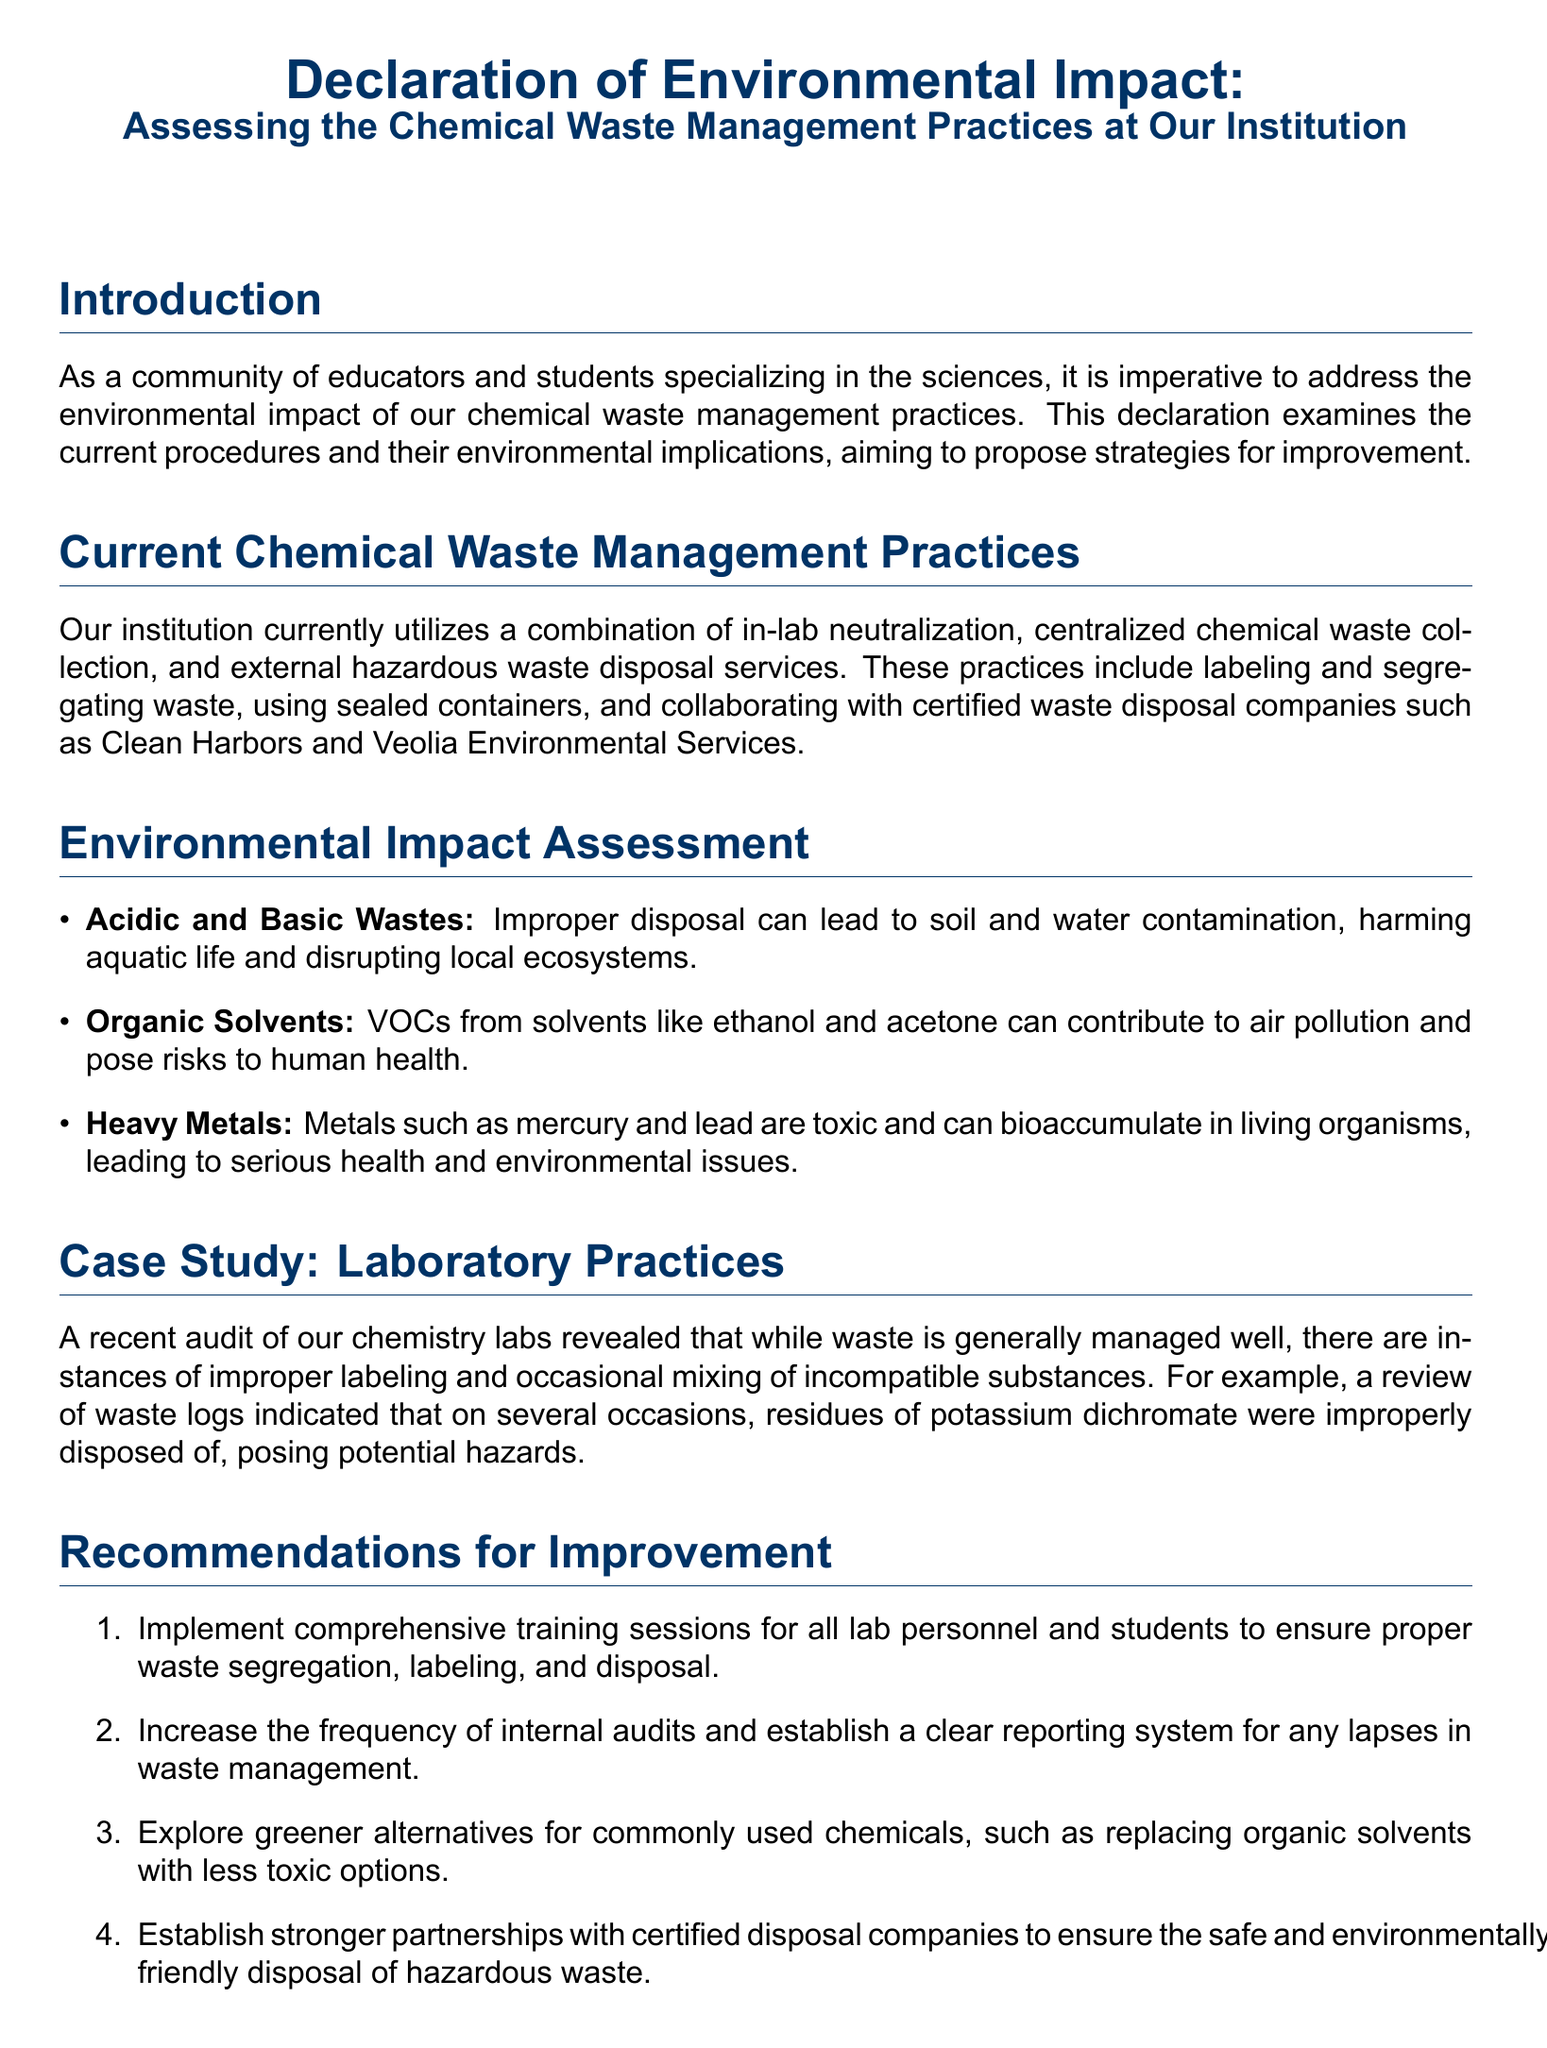What is the title of the document? The title is provided in the introduction section and is a clear representation of the document's focus.
Answer: Declaration of Environmental Impact: Assessing the Chemical Waste Management Practices at Our Institution What companies are mentioned for waste disposal? These companies are referenced in the context of external services utilized for chemical waste disposal.
Answer: Clean Harbors and Veolia Environmental Services What is one type of waste discussed in the environmental impact assessment? The document lists specific types of waste and their implications for the environment, indicating a focus on various waste categories.
Answer: Acidic and Basic Wastes What is one recommendation made for improving waste management? The recommendations section provides actionable steps aimed at enhancing current practices, reflecting on necessary changes.
Answer: Implement comprehensive training sessions What was revealed by the recent audit of the chemistry labs? The audit findings highlight specific issues related to laboratory practices that impact waste management effectiveness, showcasing areas of concern.
Answer: Improper labeling and occasional mixing of incompatible substances What does the document urge institutions to promote? The conclusion emphasizes broader goals regarding environmental responsibility and sustainable practices in waste management.
Answer: Sustainable practices What can heavy metals like mercury cause according to the document? The environmental impact assessment discusses the potential consequences of incorrect disposal of certain hazardous substances.
Answer: Serious health and environmental issues 